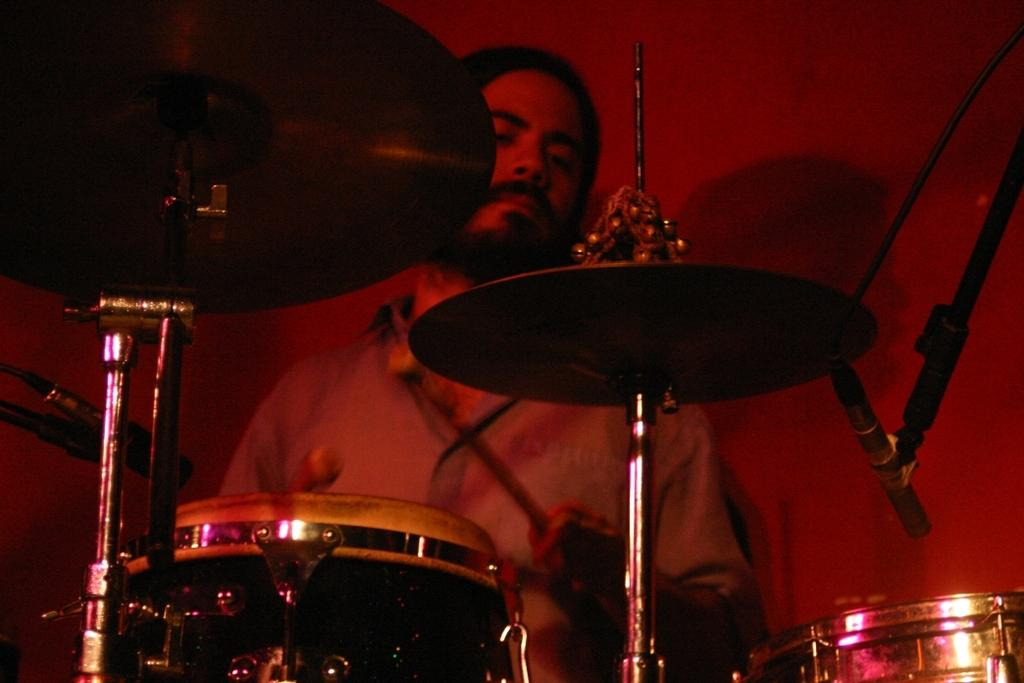Who is present in the image? There is a man present in the image. What is the man holding in his hands? The man is holding two drumsticks. What instrument is in front of the man? There is a drum set in front of the man. What devices are visible for amplifying sound? There are microphones (mics) visible in the image. What type of nest can be seen in the image? There is no nest present in the image; it features a man holding drumsticks and a drum set. 